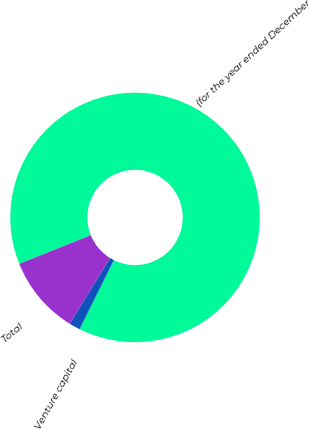Convert chart to OTSL. <chart><loc_0><loc_0><loc_500><loc_500><pie_chart><fcel>(for the year ended December<fcel>Venture capital<fcel>Total<nl><fcel>88.4%<fcel>1.45%<fcel>10.15%<nl></chart> 